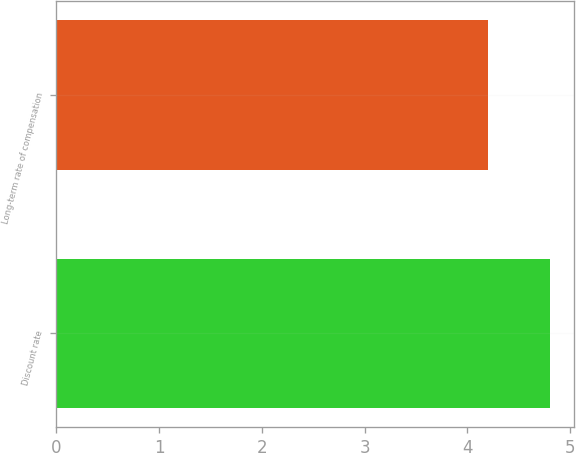Convert chart to OTSL. <chart><loc_0><loc_0><loc_500><loc_500><bar_chart><fcel>Discount rate<fcel>Long-term rate of compensation<nl><fcel>4.8<fcel>4.2<nl></chart> 